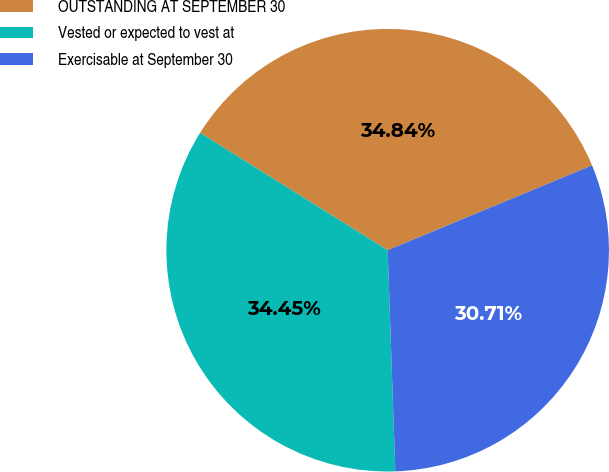<chart> <loc_0><loc_0><loc_500><loc_500><pie_chart><fcel>OUTSTANDING AT SEPTEMBER 30<fcel>Vested or expected to vest at<fcel>Exercisable at September 30<nl><fcel>34.84%<fcel>34.45%<fcel>30.71%<nl></chart> 